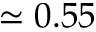Convert formula to latex. <formula><loc_0><loc_0><loc_500><loc_500>\simeq 0 . 5 5</formula> 